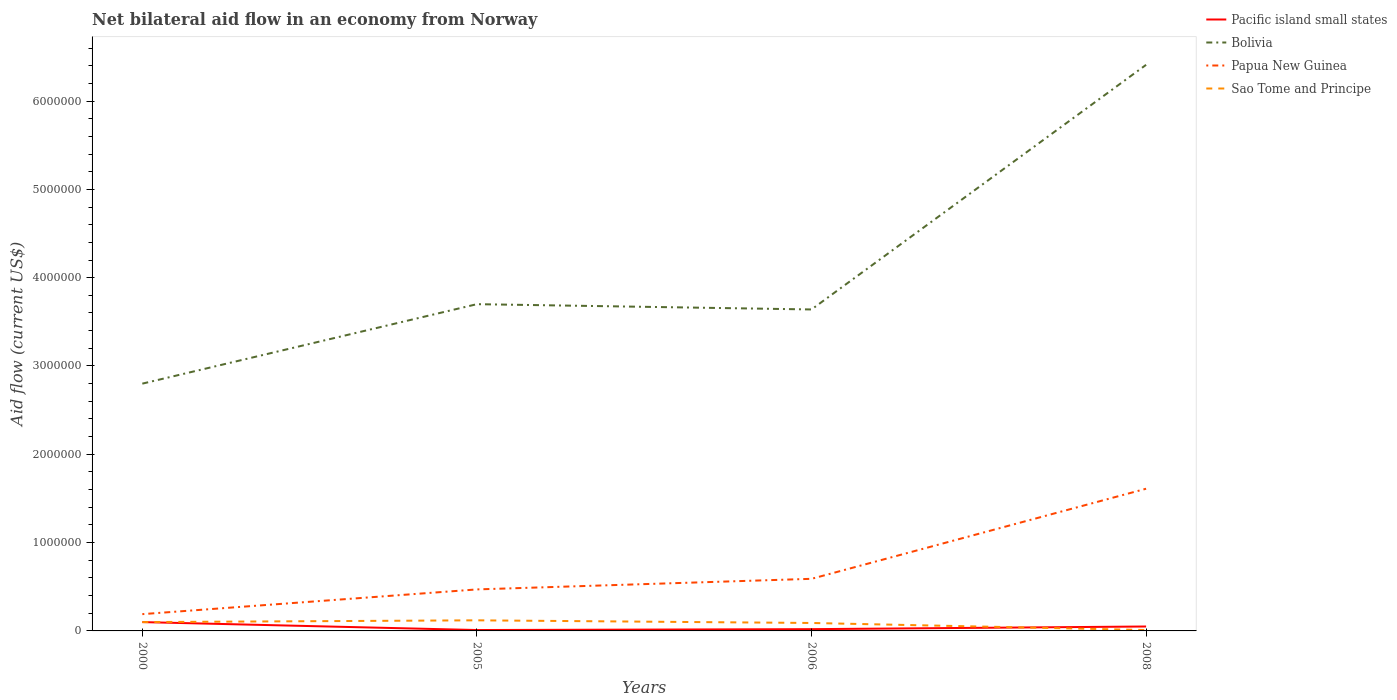How many different coloured lines are there?
Give a very brief answer. 4. Does the line corresponding to Bolivia intersect with the line corresponding to Papua New Guinea?
Give a very brief answer. No. Is the number of lines equal to the number of legend labels?
Your response must be concise. Yes. In which year was the net bilateral aid flow in Sao Tome and Principe maximum?
Offer a terse response. 2008. What is the difference between the highest and the second highest net bilateral aid flow in Sao Tome and Principe?
Your answer should be compact. 1.10e+05. What is the difference between the highest and the lowest net bilateral aid flow in Pacific island small states?
Give a very brief answer. 2. Is the net bilateral aid flow in Sao Tome and Principe strictly greater than the net bilateral aid flow in Bolivia over the years?
Your response must be concise. Yes. How many years are there in the graph?
Your answer should be compact. 4. What is the difference between two consecutive major ticks on the Y-axis?
Keep it short and to the point. 1.00e+06. Are the values on the major ticks of Y-axis written in scientific E-notation?
Your response must be concise. No. Where does the legend appear in the graph?
Your answer should be compact. Top right. What is the title of the graph?
Make the answer very short. Net bilateral aid flow in an economy from Norway. Does "High income" appear as one of the legend labels in the graph?
Your response must be concise. No. What is the Aid flow (current US$) in Pacific island small states in 2000?
Keep it short and to the point. 1.00e+05. What is the Aid flow (current US$) in Bolivia in 2000?
Ensure brevity in your answer.  2.80e+06. What is the Aid flow (current US$) of Sao Tome and Principe in 2000?
Provide a short and direct response. 1.00e+05. What is the Aid flow (current US$) of Bolivia in 2005?
Ensure brevity in your answer.  3.70e+06. What is the Aid flow (current US$) in Sao Tome and Principe in 2005?
Make the answer very short. 1.20e+05. What is the Aid flow (current US$) in Bolivia in 2006?
Your response must be concise. 3.64e+06. What is the Aid flow (current US$) in Papua New Guinea in 2006?
Make the answer very short. 5.90e+05. What is the Aid flow (current US$) of Bolivia in 2008?
Your answer should be very brief. 6.41e+06. What is the Aid flow (current US$) of Papua New Guinea in 2008?
Keep it short and to the point. 1.61e+06. What is the Aid flow (current US$) in Sao Tome and Principe in 2008?
Give a very brief answer. 10000. Across all years, what is the maximum Aid flow (current US$) of Bolivia?
Keep it short and to the point. 6.41e+06. Across all years, what is the maximum Aid flow (current US$) in Papua New Guinea?
Your answer should be compact. 1.61e+06. Across all years, what is the minimum Aid flow (current US$) of Bolivia?
Your answer should be very brief. 2.80e+06. What is the total Aid flow (current US$) in Pacific island small states in the graph?
Your answer should be very brief. 1.80e+05. What is the total Aid flow (current US$) in Bolivia in the graph?
Ensure brevity in your answer.  1.66e+07. What is the total Aid flow (current US$) in Papua New Guinea in the graph?
Your answer should be very brief. 2.86e+06. What is the difference between the Aid flow (current US$) in Pacific island small states in 2000 and that in 2005?
Ensure brevity in your answer.  9.00e+04. What is the difference between the Aid flow (current US$) in Bolivia in 2000 and that in 2005?
Offer a very short reply. -9.00e+05. What is the difference between the Aid flow (current US$) of Papua New Guinea in 2000 and that in 2005?
Provide a succinct answer. -2.80e+05. What is the difference between the Aid flow (current US$) of Bolivia in 2000 and that in 2006?
Ensure brevity in your answer.  -8.40e+05. What is the difference between the Aid flow (current US$) of Papua New Guinea in 2000 and that in 2006?
Provide a short and direct response. -4.00e+05. What is the difference between the Aid flow (current US$) in Pacific island small states in 2000 and that in 2008?
Offer a very short reply. 5.00e+04. What is the difference between the Aid flow (current US$) of Bolivia in 2000 and that in 2008?
Give a very brief answer. -3.61e+06. What is the difference between the Aid flow (current US$) of Papua New Guinea in 2000 and that in 2008?
Your answer should be very brief. -1.42e+06. What is the difference between the Aid flow (current US$) of Bolivia in 2005 and that in 2006?
Give a very brief answer. 6.00e+04. What is the difference between the Aid flow (current US$) of Sao Tome and Principe in 2005 and that in 2006?
Ensure brevity in your answer.  3.00e+04. What is the difference between the Aid flow (current US$) in Bolivia in 2005 and that in 2008?
Give a very brief answer. -2.71e+06. What is the difference between the Aid flow (current US$) in Papua New Guinea in 2005 and that in 2008?
Provide a short and direct response. -1.14e+06. What is the difference between the Aid flow (current US$) in Pacific island small states in 2006 and that in 2008?
Your answer should be compact. -3.00e+04. What is the difference between the Aid flow (current US$) of Bolivia in 2006 and that in 2008?
Make the answer very short. -2.77e+06. What is the difference between the Aid flow (current US$) in Papua New Guinea in 2006 and that in 2008?
Offer a terse response. -1.02e+06. What is the difference between the Aid flow (current US$) in Pacific island small states in 2000 and the Aid flow (current US$) in Bolivia in 2005?
Your answer should be compact. -3.60e+06. What is the difference between the Aid flow (current US$) of Pacific island small states in 2000 and the Aid flow (current US$) of Papua New Guinea in 2005?
Give a very brief answer. -3.70e+05. What is the difference between the Aid flow (current US$) in Pacific island small states in 2000 and the Aid flow (current US$) in Sao Tome and Principe in 2005?
Offer a terse response. -2.00e+04. What is the difference between the Aid flow (current US$) in Bolivia in 2000 and the Aid flow (current US$) in Papua New Guinea in 2005?
Provide a succinct answer. 2.33e+06. What is the difference between the Aid flow (current US$) in Bolivia in 2000 and the Aid flow (current US$) in Sao Tome and Principe in 2005?
Provide a succinct answer. 2.68e+06. What is the difference between the Aid flow (current US$) in Papua New Guinea in 2000 and the Aid flow (current US$) in Sao Tome and Principe in 2005?
Keep it short and to the point. 7.00e+04. What is the difference between the Aid flow (current US$) in Pacific island small states in 2000 and the Aid flow (current US$) in Bolivia in 2006?
Offer a terse response. -3.54e+06. What is the difference between the Aid flow (current US$) of Pacific island small states in 2000 and the Aid flow (current US$) of Papua New Guinea in 2006?
Give a very brief answer. -4.90e+05. What is the difference between the Aid flow (current US$) of Bolivia in 2000 and the Aid flow (current US$) of Papua New Guinea in 2006?
Make the answer very short. 2.21e+06. What is the difference between the Aid flow (current US$) of Bolivia in 2000 and the Aid flow (current US$) of Sao Tome and Principe in 2006?
Your response must be concise. 2.71e+06. What is the difference between the Aid flow (current US$) in Papua New Guinea in 2000 and the Aid flow (current US$) in Sao Tome and Principe in 2006?
Keep it short and to the point. 1.00e+05. What is the difference between the Aid flow (current US$) of Pacific island small states in 2000 and the Aid flow (current US$) of Bolivia in 2008?
Give a very brief answer. -6.31e+06. What is the difference between the Aid flow (current US$) of Pacific island small states in 2000 and the Aid flow (current US$) of Papua New Guinea in 2008?
Ensure brevity in your answer.  -1.51e+06. What is the difference between the Aid flow (current US$) of Pacific island small states in 2000 and the Aid flow (current US$) of Sao Tome and Principe in 2008?
Ensure brevity in your answer.  9.00e+04. What is the difference between the Aid flow (current US$) in Bolivia in 2000 and the Aid flow (current US$) in Papua New Guinea in 2008?
Make the answer very short. 1.19e+06. What is the difference between the Aid flow (current US$) in Bolivia in 2000 and the Aid flow (current US$) in Sao Tome and Principe in 2008?
Your answer should be very brief. 2.79e+06. What is the difference between the Aid flow (current US$) of Pacific island small states in 2005 and the Aid flow (current US$) of Bolivia in 2006?
Give a very brief answer. -3.63e+06. What is the difference between the Aid flow (current US$) of Pacific island small states in 2005 and the Aid flow (current US$) of Papua New Guinea in 2006?
Offer a terse response. -5.80e+05. What is the difference between the Aid flow (current US$) in Bolivia in 2005 and the Aid flow (current US$) in Papua New Guinea in 2006?
Keep it short and to the point. 3.11e+06. What is the difference between the Aid flow (current US$) in Bolivia in 2005 and the Aid flow (current US$) in Sao Tome and Principe in 2006?
Your answer should be very brief. 3.61e+06. What is the difference between the Aid flow (current US$) of Papua New Guinea in 2005 and the Aid flow (current US$) of Sao Tome and Principe in 2006?
Provide a succinct answer. 3.80e+05. What is the difference between the Aid flow (current US$) in Pacific island small states in 2005 and the Aid flow (current US$) in Bolivia in 2008?
Give a very brief answer. -6.40e+06. What is the difference between the Aid flow (current US$) in Pacific island small states in 2005 and the Aid flow (current US$) in Papua New Guinea in 2008?
Provide a short and direct response. -1.60e+06. What is the difference between the Aid flow (current US$) of Bolivia in 2005 and the Aid flow (current US$) of Papua New Guinea in 2008?
Offer a very short reply. 2.09e+06. What is the difference between the Aid flow (current US$) in Bolivia in 2005 and the Aid flow (current US$) in Sao Tome and Principe in 2008?
Give a very brief answer. 3.69e+06. What is the difference between the Aid flow (current US$) of Papua New Guinea in 2005 and the Aid flow (current US$) of Sao Tome and Principe in 2008?
Your answer should be compact. 4.60e+05. What is the difference between the Aid flow (current US$) of Pacific island small states in 2006 and the Aid flow (current US$) of Bolivia in 2008?
Offer a very short reply. -6.39e+06. What is the difference between the Aid flow (current US$) of Pacific island small states in 2006 and the Aid flow (current US$) of Papua New Guinea in 2008?
Provide a short and direct response. -1.59e+06. What is the difference between the Aid flow (current US$) of Pacific island small states in 2006 and the Aid flow (current US$) of Sao Tome and Principe in 2008?
Make the answer very short. 10000. What is the difference between the Aid flow (current US$) of Bolivia in 2006 and the Aid flow (current US$) of Papua New Guinea in 2008?
Give a very brief answer. 2.03e+06. What is the difference between the Aid flow (current US$) of Bolivia in 2006 and the Aid flow (current US$) of Sao Tome and Principe in 2008?
Provide a succinct answer. 3.63e+06. What is the difference between the Aid flow (current US$) of Papua New Guinea in 2006 and the Aid flow (current US$) of Sao Tome and Principe in 2008?
Make the answer very short. 5.80e+05. What is the average Aid flow (current US$) of Pacific island small states per year?
Your answer should be compact. 4.50e+04. What is the average Aid flow (current US$) in Bolivia per year?
Provide a short and direct response. 4.14e+06. What is the average Aid flow (current US$) in Papua New Guinea per year?
Offer a terse response. 7.15e+05. In the year 2000, what is the difference between the Aid flow (current US$) of Pacific island small states and Aid flow (current US$) of Bolivia?
Offer a very short reply. -2.70e+06. In the year 2000, what is the difference between the Aid flow (current US$) of Pacific island small states and Aid flow (current US$) of Papua New Guinea?
Offer a terse response. -9.00e+04. In the year 2000, what is the difference between the Aid flow (current US$) in Bolivia and Aid flow (current US$) in Papua New Guinea?
Your response must be concise. 2.61e+06. In the year 2000, what is the difference between the Aid flow (current US$) in Bolivia and Aid flow (current US$) in Sao Tome and Principe?
Keep it short and to the point. 2.70e+06. In the year 2000, what is the difference between the Aid flow (current US$) of Papua New Guinea and Aid flow (current US$) of Sao Tome and Principe?
Keep it short and to the point. 9.00e+04. In the year 2005, what is the difference between the Aid flow (current US$) in Pacific island small states and Aid flow (current US$) in Bolivia?
Ensure brevity in your answer.  -3.69e+06. In the year 2005, what is the difference between the Aid flow (current US$) in Pacific island small states and Aid flow (current US$) in Papua New Guinea?
Make the answer very short. -4.60e+05. In the year 2005, what is the difference between the Aid flow (current US$) of Pacific island small states and Aid flow (current US$) of Sao Tome and Principe?
Make the answer very short. -1.10e+05. In the year 2005, what is the difference between the Aid flow (current US$) of Bolivia and Aid flow (current US$) of Papua New Guinea?
Offer a very short reply. 3.23e+06. In the year 2005, what is the difference between the Aid flow (current US$) in Bolivia and Aid flow (current US$) in Sao Tome and Principe?
Provide a short and direct response. 3.58e+06. In the year 2006, what is the difference between the Aid flow (current US$) in Pacific island small states and Aid flow (current US$) in Bolivia?
Your answer should be very brief. -3.62e+06. In the year 2006, what is the difference between the Aid flow (current US$) in Pacific island small states and Aid flow (current US$) in Papua New Guinea?
Provide a succinct answer. -5.70e+05. In the year 2006, what is the difference between the Aid flow (current US$) of Bolivia and Aid flow (current US$) of Papua New Guinea?
Ensure brevity in your answer.  3.05e+06. In the year 2006, what is the difference between the Aid flow (current US$) in Bolivia and Aid flow (current US$) in Sao Tome and Principe?
Provide a short and direct response. 3.55e+06. In the year 2008, what is the difference between the Aid flow (current US$) of Pacific island small states and Aid flow (current US$) of Bolivia?
Offer a terse response. -6.36e+06. In the year 2008, what is the difference between the Aid flow (current US$) in Pacific island small states and Aid flow (current US$) in Papua New Guinea?
Offer a very short reply. -1.56e+06. In the year 2008, what is the difference between the Aid flow (current US$) of Pacific island small states and Aid flow (current US$) of Sao Tome and Principe?
Your answer should be compact. 4.00e+04. In the year 2008, what is the difference between the Aid flow (current US$) of Bolivia and Aid flow (current US$) of Papua New Guinea?
Offer a terse response. 4.80e+06. In the year 2008, what is the difference between the Aid flow (current US$) in Bolivia and Aid flow (current US$) in Sao Tome and Principe?
Your answer should be compact. 6.40e+06. In the year 2008, what is the difference between the Aid flow (current US$) of Papua New Guinea and Aid flow (current US$) of Sao Tome and Principe?
Keep it short and to the point. 1.60e+06. What is the ratio of the Aid flow (current US$) of Bolivia in 2000 to that in 2005?
Give a very brief answer. 0.76. What is the ratio of the Aid flow (current US$) in Papua New Guinea in 2000 to that in 2005?
Offer a terse response. 0.4. What is the ratio of the Aid flow (current US$) in Bolivia in 2000 to that in 2006?
Provide a short and direct response. 0.77. What is the ratio of the Aid flow (current US$) of Papua New Guinea in 2000 to that in 2006?
Ensure brevity in your answer.  0.32. What is the ratio of the Aid flow (current US$) in Bolivia in 2000 to that in 2008?
Your answer should be compact. 0.44. What is the ratio of the Aid flow (current US$) in Papua New Guinea in 2000 to that in 2008?
Offer a very short reply. 0.12. What is the ratio of the Aid flow (current US$) of Pacific island small states in 2005 to that in 2006?
Offer a very short reply. 0.5. What is the ratio of the Aid flow (current US$) of Bolivia in 2005 to that in 2006?
Your response must be concise. 1.02. What is the ratio of the Aid flow (current US$) of Papua New Guinea in 2005 to that in 2006?
Give a very brief answer. 0.8. What is the ratio of the Aid flow (current US$) in Sao Tome and Principe in 2005 to that in 2006?
Make the answer very short. 1.33. What is the ratio of the Aid flow (current US$) in Bolivia in 2005 to that in 2008?
Your answer should be very brief. 0.58. What is the ratio of the Aid flow (current US$) of Papua New Guinea in 2005 to that in 2008?
Ensure brevity in your answer.  0.29. What is the ratio of the Aid flow (current US$) of Bolivia in 2006 to that in 2008?
Keep it short and to the point. 0.57. What is the ratio of the Aid flow (current US$) in Papua New Guinea in 2006 to that in 2008?
Give a very brief answer. 0.37. What is the difference between the highest and the second highest Aid flow (current US$) in Bolivia?
Make the answer very short. 2.71e+06. What is the difference between the highest and the second highest Aid flow (current US$) of Papua New Guinea?
Provide a short and direct response. 1.02e+06. What is the difference between the highest and the second highest Aid flow (current US$) of Sao Tome and Principe?
Ensure brevity in your answer.  2.00e+04. What is the difference between the highest and the lowest Aid flow (current US$) of Bolivia?
Your answer should be compact. 3.61e+06. What is the difference between the highest and the lowest Aid flow (current US$) in Papua New Guinea?
Provide a short and direct response. 1.42e+06. What is the difference between the highest and the lowest Aid flow (current US$) of Sao Tome and Principe?
Keep it short and to the point. 1.10e+05. 